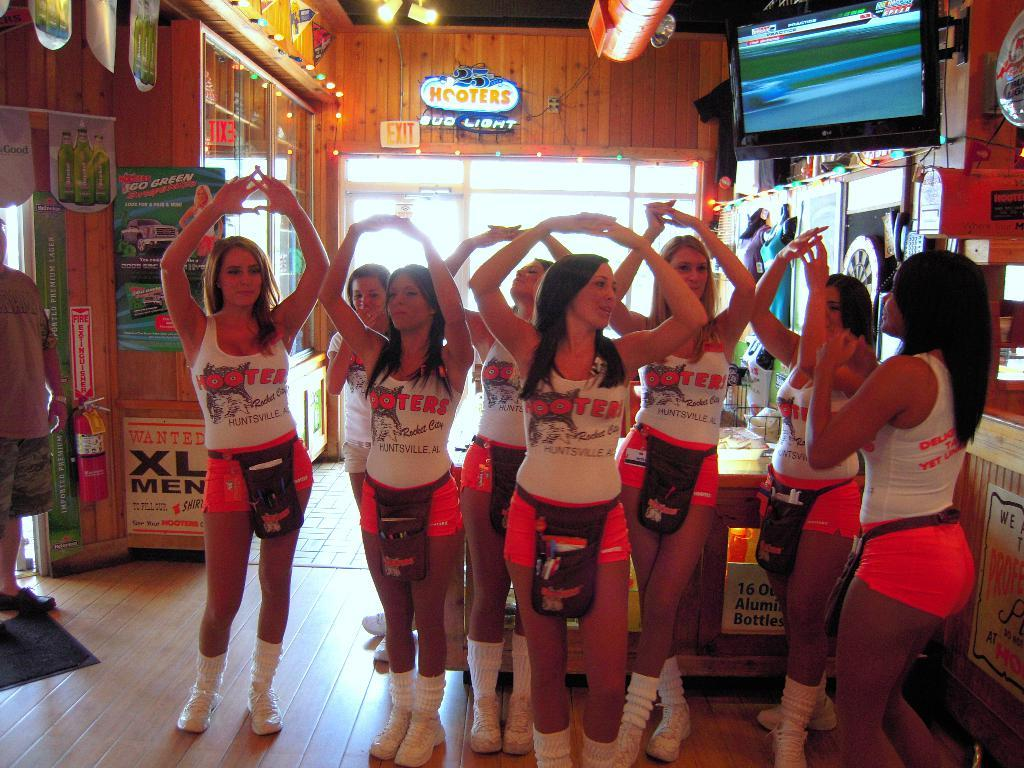<image>
Describe the image concisely. women wearing Hooters tshirts hold their hand in the air 